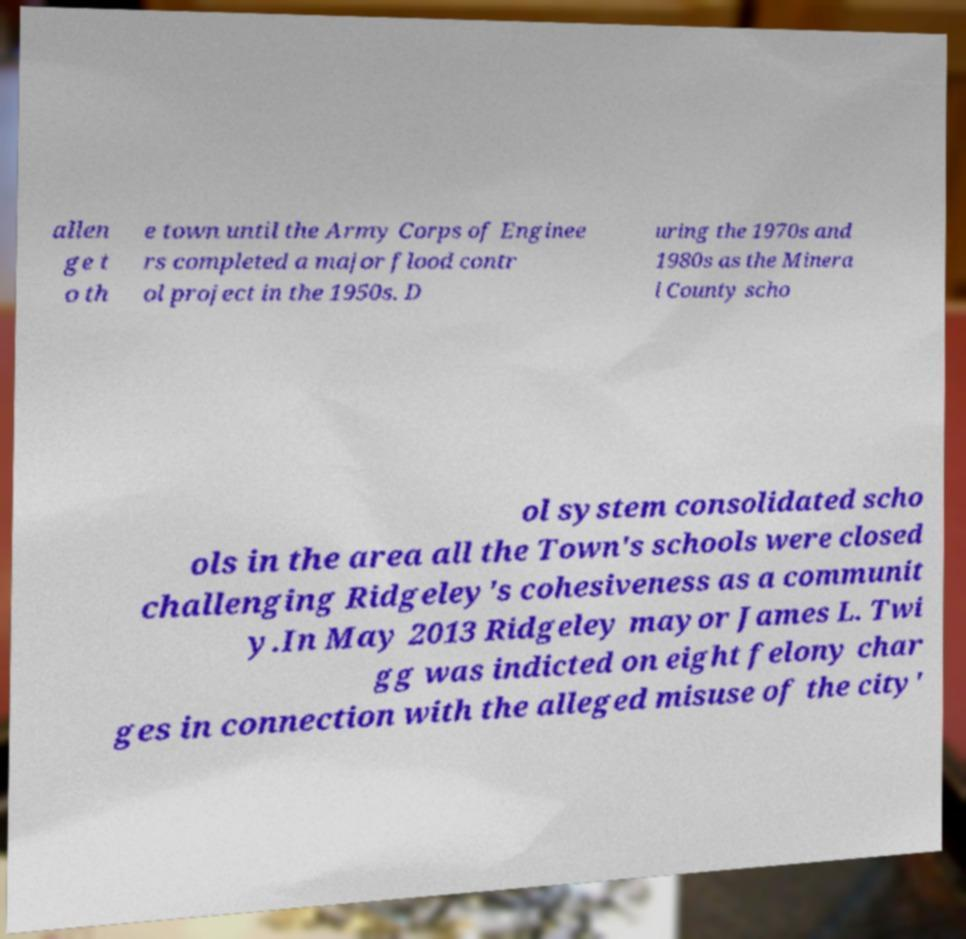Could you extract and type out the text from this image? allen ge t o th e town until the Army Corps of Enginee rs completed a major flood contr ol project in the 1950s. D uring the 1970s and 1980s as the Minera l County scho ol system consolidated scho ols in the area all the Town's schools were closed challenging Ridgeley's cohesiveness as a communit y.In May 2013 Ridgeley mayor James L. Twi gg was indicted on eight felony char ges in connection with the alleged misuse of the city' 